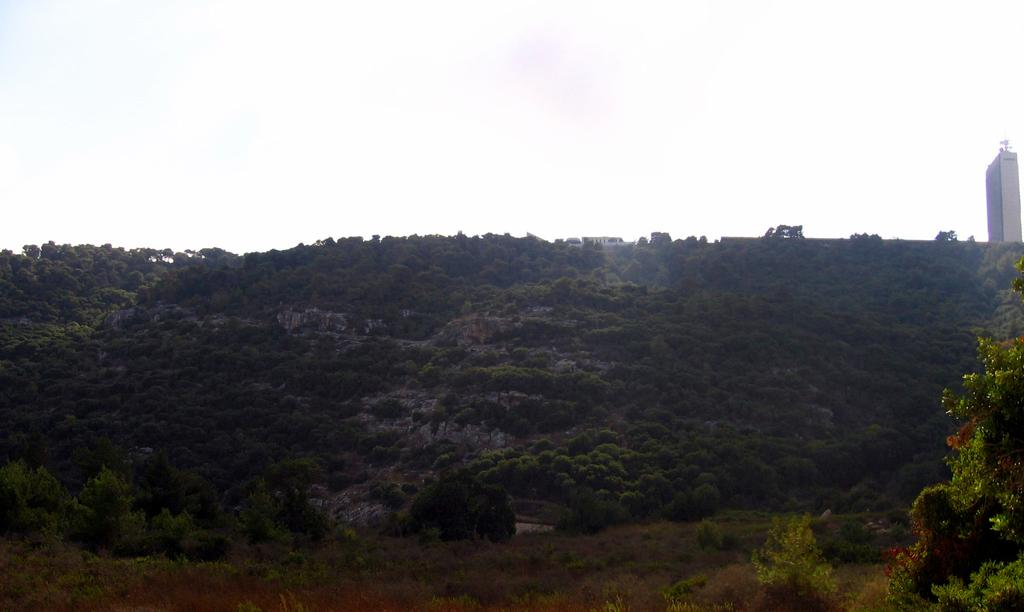What type of vegetation is present in the image? There are trees in the image. What structure can be seen in the image? There is a tower in the image. What type of shoe is hanging from the tree in the image? There is no shoe hanging from the tree in the image; only trees and a tower are present. Can you tell me if the tower in the image has received approval for construction? There is no information about approval for the tower in the image; we can only observe its presence in the image. 